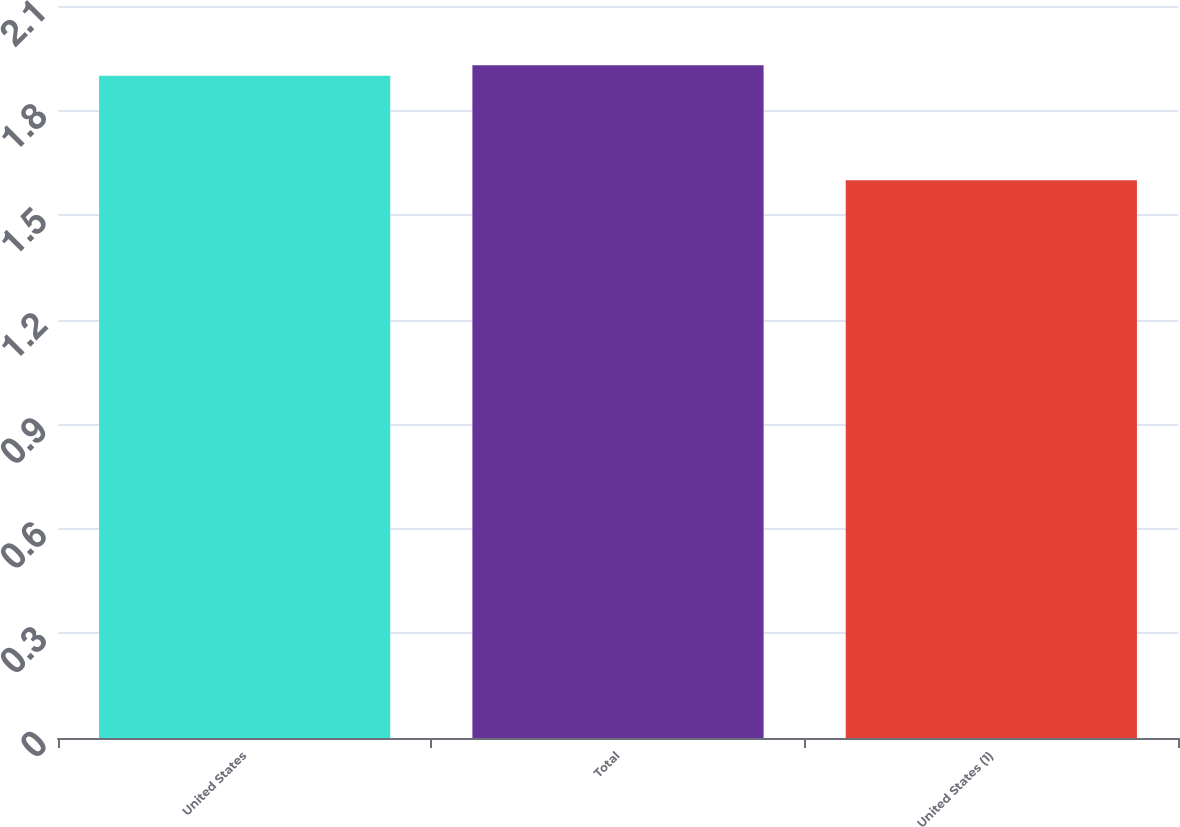Convert chart to OTSL. <chart><loc_0><loc_0><loc_500><loc_500><bar_chart><fcel>United States<fcel>Total<fcel>United States (1)<nl><fcel>1.9<fcel>1.93<fcel>1.6<nl></chart> 